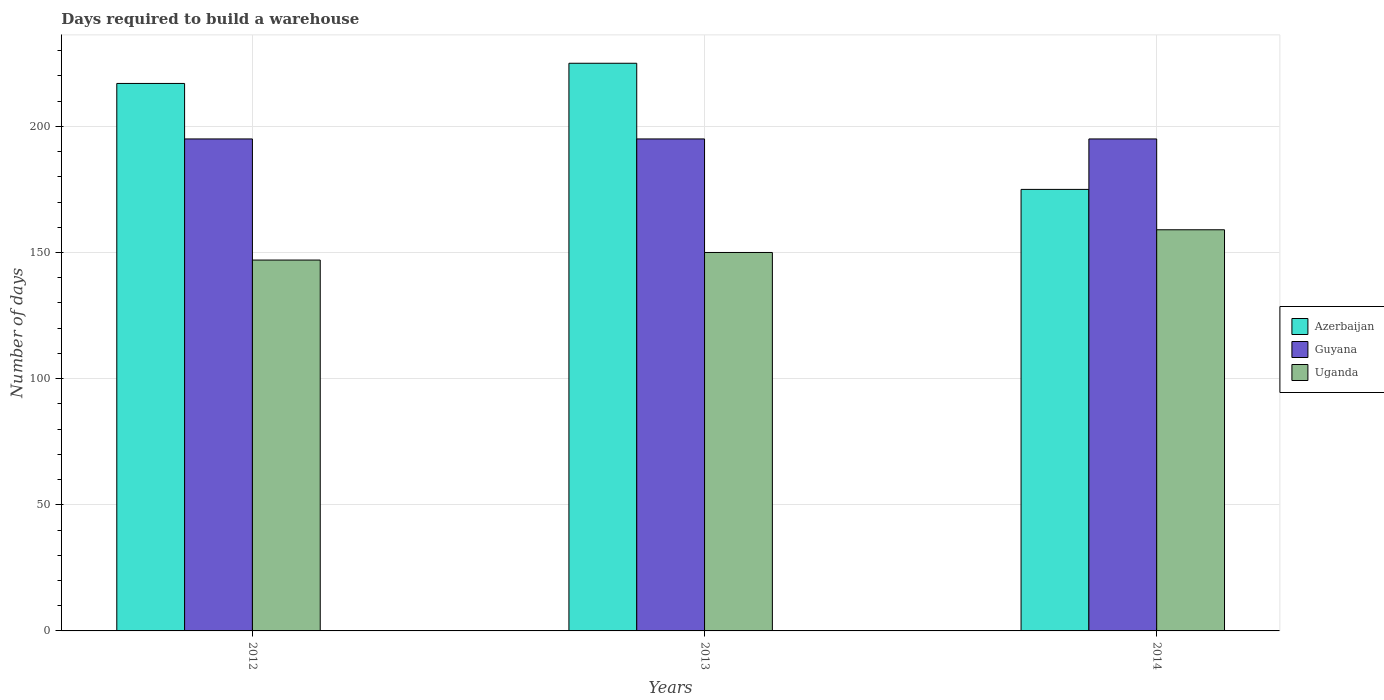How many groups of bars are there?
Provide a succinct answer. 3. Are the number of bars per tick equal to the number of legend labels?
Ensure brevity in your answer.  Yes. Are the number of bars on each tick of the X-axis equal?
Offer a terse response. Yes. How many bars are there on the 1st tick from the right?
Make the answer very short. 3. What is the days required to build a warehouse in in Azerbaijan in 2013?
Your answer should be compact. 225. Across all years, what is the maximum days required to build a warehouse in in Uganda?
Provide a succinct answer. 159. Across all years, what is the minimum days required to build a warehouse in in Azerbaijan?
Your answer should be very brief. 175. In which year was the days required to build a warehouse in in Guyana maximum?
Offer a very short reply. 2012. What is the total days required to build a warehouse in in Uganda in the graph?
Provide a short and direct response. 456. What is the difference between the days required to build a warehouse in in Azerbaijan in 2012 and that in 2014?
Make the answer very short. 42. What is the difference between the days required to build a warehouse in in Guyana in 2014 and the days required to build a warehouse in in Azerbaijan in 2012?
Offer a terse response. -22. What is the average days required to build a warehouse in in Guyana per year?
Keep it short and to the point. 195. In the year 2014, what is the difference between the days required to build a warehouse in in Uganda and days required to build a warehouse in in Guyana?
Ensure brevity in your answer.  -36. What is the ratio of the days required to build a warehouse in in Azerbaijan in 2013 to that in 2014?
Make the answer very short. 1.29. Is the days required to build a warehouse in in Uganda in 2013 less than that in 2014?
Your answer should be compact. Yes. What is the difference between the highest and the second highest days required to build a warehouse in in Azerbaijan?
Ensure brevity in your answer.  8. What is the difference between the highest and the lowest days required to build a warehouse in in Uganda?
Provide a succinct answer. 12. What does the 2nd bar from the left in 2013 represents?
Give a very brief answer. Guyana. What does the 2nd bar from the right in 2013 represents?
Offer a terse response. Guyana. Is it the case that in every year, the sum of the days required to build a warehouse in in Guyana and days required to build a warehouse in in Azerbaijan is greater than the days required to build a warehouse in in Uganda?
Make the answer very short. Yes. What is the difference between two consecutive major ticks on the Y-axis?
Give a very brief answer. 50. Does the graph contain any zero values?
Make the answer very short. No. Does the graph contain grids?
Provide a short and direct response. Yes. Where does the legend appear in the graph?
Provide a short and direct response. Center right. How many legend labels are there?
Make the answer very short. 3. What is the title of the graph?
Make the answer very short. Days required to build a warehouse. What is the label or title of the Y-axis?
Provide a succinct answer. Number of days. What is the Number of days in Azerbaijan in 2012?
Make the answer very short. 217. What is the Number of days in Guyana in 2012?
Your response must be concise. 195. What is the Number of days of Uganda in 2012?
Make the answer very short. 147. What is the Number of days in Azerbaijan in 2013?
Provide a short and direct response. 225. What is the Number of days in Guyana in 2013?
Make the answer very short. 195. What is the Number of days of Uganda in 2013?
Your answer should be compact. 150. What is the Number of days in Azerbaijan in 2014?
Give a very brief answer. 175. What is the Number of days of Guyana in 2014?
Give a very brief answer. 195. What is the Number of days of Uganda in 2014?
Provide a succinct answer. 159. Across all years, what is the maximum Number of days in Azerbaijan?
Your response must be concise. 225. Across all years, what is the maximum Number of days in Guyana?
Offer a very short reply. 195. Across all years, what is the maximum Number of days in Uganda?
Keep it short and to the point. 159. Across all years, what is the minimum Number of days of Azerbaijan?
Keep it short and to the point. 175. Across all years, what is the minimum Number of days in Guyana?
Offer a very short reply. 195. Across all years, what is the minimum Number of days in Uganda?
Keep it short and to the point. 147. What is the total Number of days in Azerbaijan in the graph?
Give a very brief answer. 617. What is the total Number of days of Guyana in the graph?
Give a very brief answer. 585. What is the total Number of days of Uganda in the graph?
Your response must be concise. 456. What is the difference between the Number of days in Guyana in 2012 and that in 2013?
Provide a short and direct response. 0. What is the difference between the Number of days of Azerbaijan in 2013 and that in 2014?
Provide a succinct answer. 50. What is the difference between the Number of days of Uganda in 2013 and that in 2014?
Make the answer very short. -9. What is the difference between the Number of days in Azerbaijan in 2012 and the Number of days in Uganda in 2013?
Your response must be concise. 67. What is the difference between the Number of days in Guyana in 2012 and the Number of days in Uganda in 2014?
Make the answer very short. 36. What is the difference between the Number of days of Azerbaijan in 2013 and the Number of days of Guyana in 2014?
Your response must be concise. 30. What is the difference between the Number of days in Guyana in 2013 and the Number of days in Uganda in 2014?
Make the answer very short. 36. What is the average Number of days in Azerbaijan per year?
Offer a terse response. 205.67. What is the average Number of days of Guyana per year?
Ensure brevity in your answer.  195. What is the average Number of days of Uganda per year?
Offer a terse response. 152. In the year 2012, what is the difference between the Number of days in Azerbaijan and Number of days in Uganda?
Keep it short and to the point. 70. In the year 2014, what is the difference between the Number of days of Guyana and Number of days of Uganda?
Your response must be concise. 36. What is the ratio of the Number of days of Azerbaijan in 2012 to that in 2013?
Your response must be concise. 0.96. What is the ratio of the Number of days in Azerbaijan in 2012 to that in 2014?
Give a very brief answer. 1.24. What is the ratio of the Number of days in Uganda in 2012 to that in 2014?
Your response must be concise. 0.92. What is the ratio of the Number of days of Azerbaijan in 2013 to that in 2014?
Offer a terse response. 1.29. What is the ratio of the Number of days in Guyana in 2013 to that in 2014?
Your answer should be compact. 1. What is the ratio of the Number of days of Uganda in 2013 to that in 2014?
Offer a very short reply. 0.94. What is the difference between the highest and the second highest Number of days in Uganda?
Your answer should be compact. 9. What is the difference between the highest and the lowest Number of days of Azerbaijan?
Your response must be concise. 50. What is the difference between the highest and the lowest Number of days of Uganda?
Offer a very short reply. 12. 